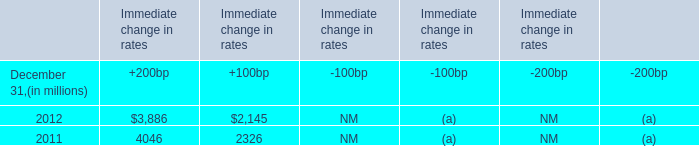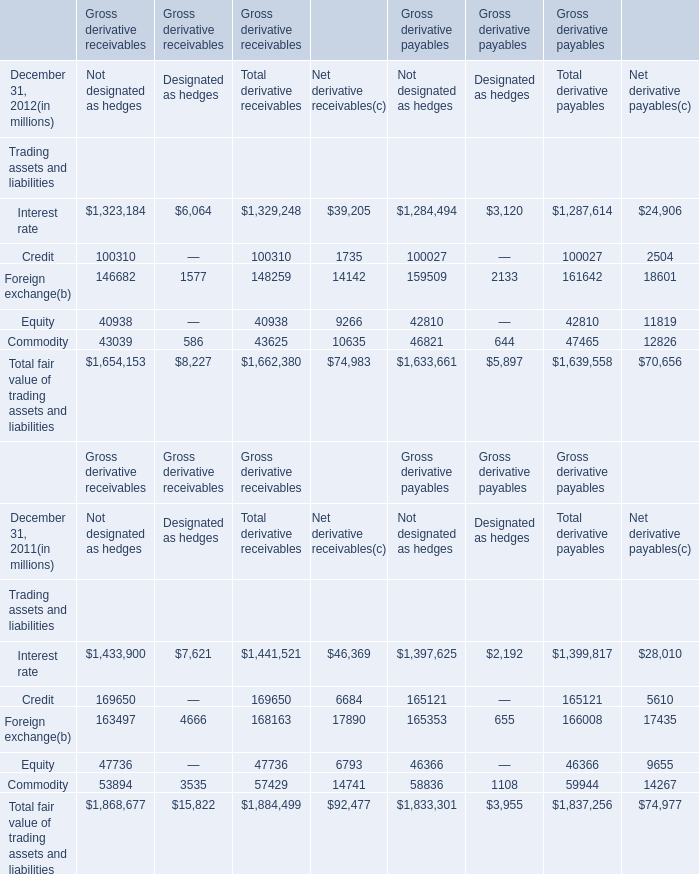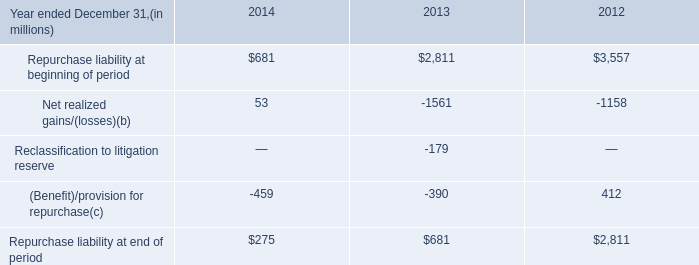Which year is Credit the highest for Not designated as hedges? 
Answer: 2011. 